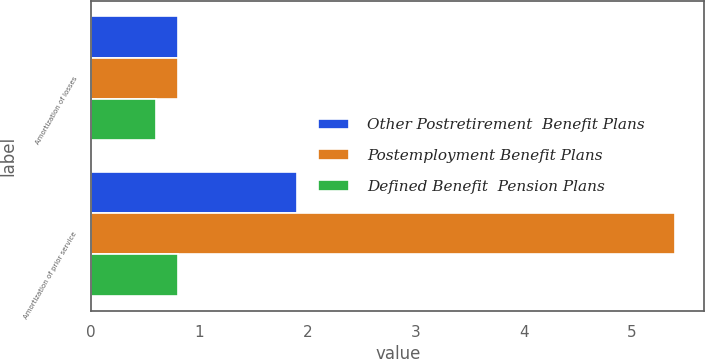<chart> <loc_0><loc_0><loc_500><loc_500><stacked_bar_chart><ecel><fcel>Amortization of losses<fcel>Amortization of prior service<nl><fcel>Other Postretirement  Benefit Plans<fcel>0.8<fcel>1.9<nl><fcel>Postemployment Benefit Plans<fcel>0.8<fcel>5.4<nl><fcel>Defined Benefit  Pension Plans<fcel>0.6<fcel>0.8<nl></chart> 